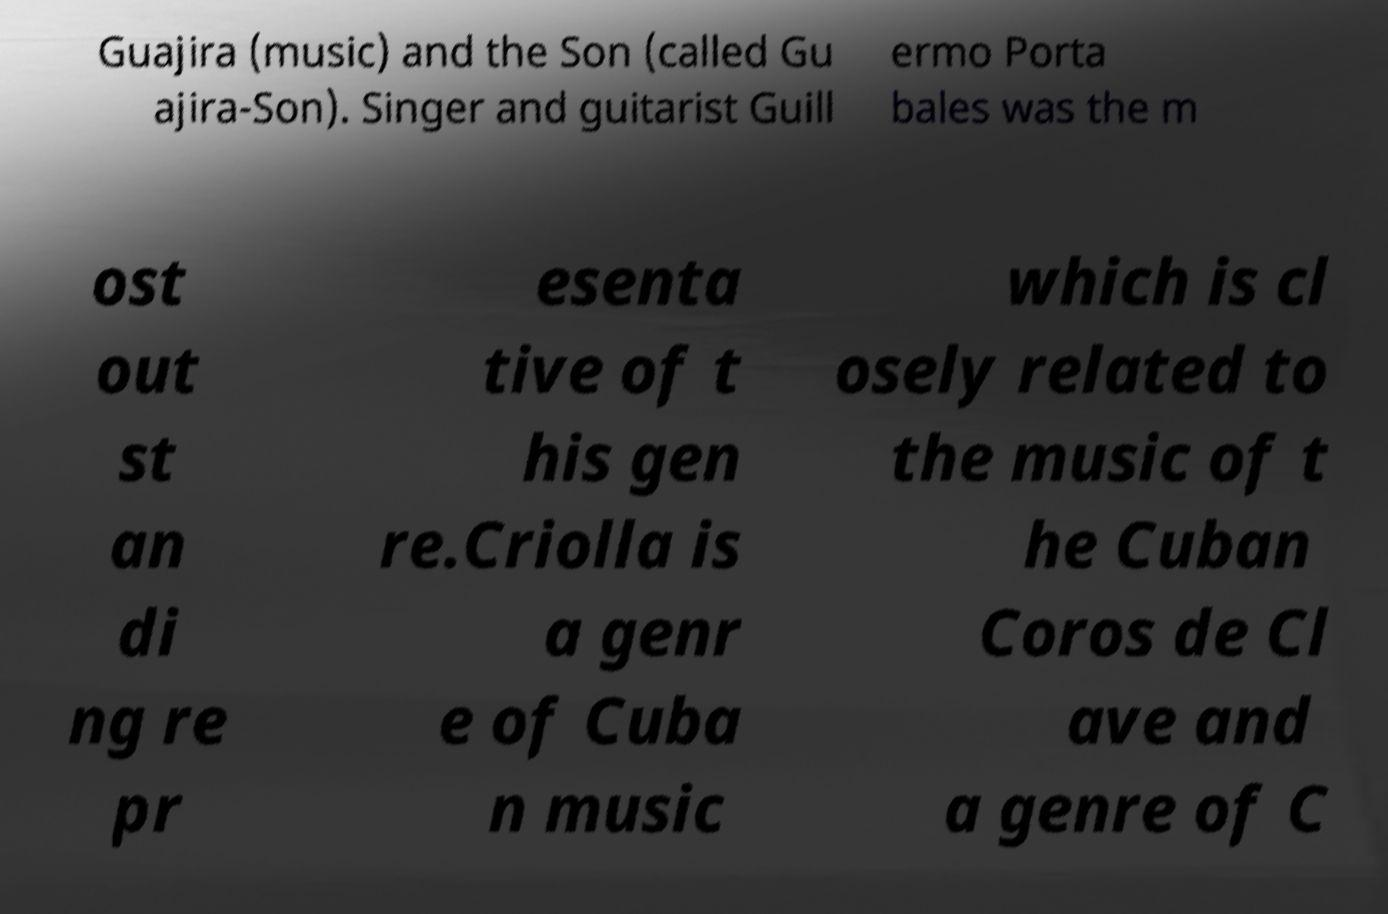Please read and relay the text visible in this image. What does it say? Guajira (music) and the Son (called Gu ajira-Son). Singer and guitarist Guill ermo Porta bales was the m ost out st an di ng re pr esenta tive of t his gen re.Criolla is a genr e of Cuba n music which is cl osely related to the music of t he Cuban Coros de Cl ave and a genre of C 